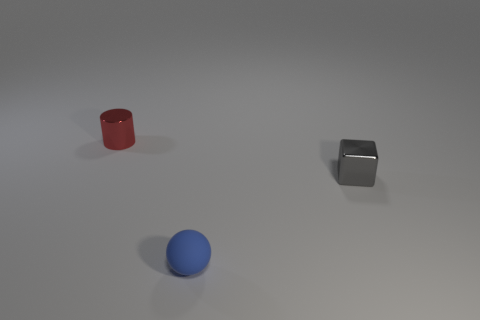How would you describe the setting of the objects? The objects are placed on a flat surface with a uniform, slightly reflective quality, under what appears to be diffuse lighting. The background is featureless and neutral in color, creating a minimalist setting that draws focus to the objects. 